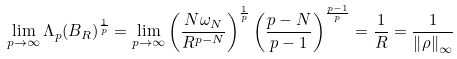Convert formula to latex. <formula><loc_0><loc_0><loc_500><loc_500>\lim _ { p \rightarrow \infty } \Lambda _ { p } ( B _ { R } ) ^ { \frac { 1 } { p } } = \lim _ { p \rightarrow \infty } \left ( \frac { N \omega _ { N } } { R ^ { p - N } } \right ) ^ { \frac { 1 } { p } } \left ( \frac { p - N } { p - 1 } \right ) ^ { \frac { p - 1 } { p } } = \frac { 1 } { R } = \frac { 1 } { \left \| \rho \right \| _ { \infty } }</formula> 